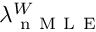<formula> <loc_0><loc_0><loc_500><loc_500>\lambda _ { n M L E } ^ { W }</formula> 